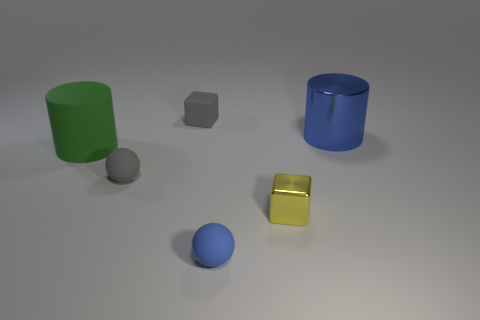The tiny cube behind the green rubber thing is what color?
Your answer should be compact. Gray. Is the number of yellow metallic blocks that are to the left of the yellow metal cube less than the number of brown matte spheres?
Your response must be concise. No. What size is the rubber object that is the same color as the large metal object?
Offer a terse response. Small. Are the tiny gray block and the big blue object made of the same material?
Your response must be concise. No. How many things are either big metallic cylinders that are behind the blue matte ball or large objects that are on the right side of the small blue object?
Provide a succinct answer. 1. Are there any yellow metallic cubes of the same size as the blue metallic cylinder?
Your answer should be compact. No. There is another small thing that is the same shape as the yellow shiny object; what is its color?
Provide a succinct answer. Gray. Are there any small things in front of the matte thing that is behind the green object?
Keep it short and to the point. Yes. Is the shape of the blue thing that is to the right of the small blue sphere the same as  the small yellow metal thing?
Provide a short and direct response. No. What shape is the blue shiny thing?
Provide a succinct answer. Cylinder. 